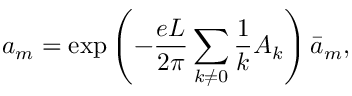<formula> <loc_0><loc_0><loc_500><loc_500>a _ { m } = e x p \left ( - \frac { e L } { 2 \pi } \sum _ { k \neq 0 } \frac { 1 } { k } A _ { k } \right ) { \bar { a } } _ { m } ,</formula> 